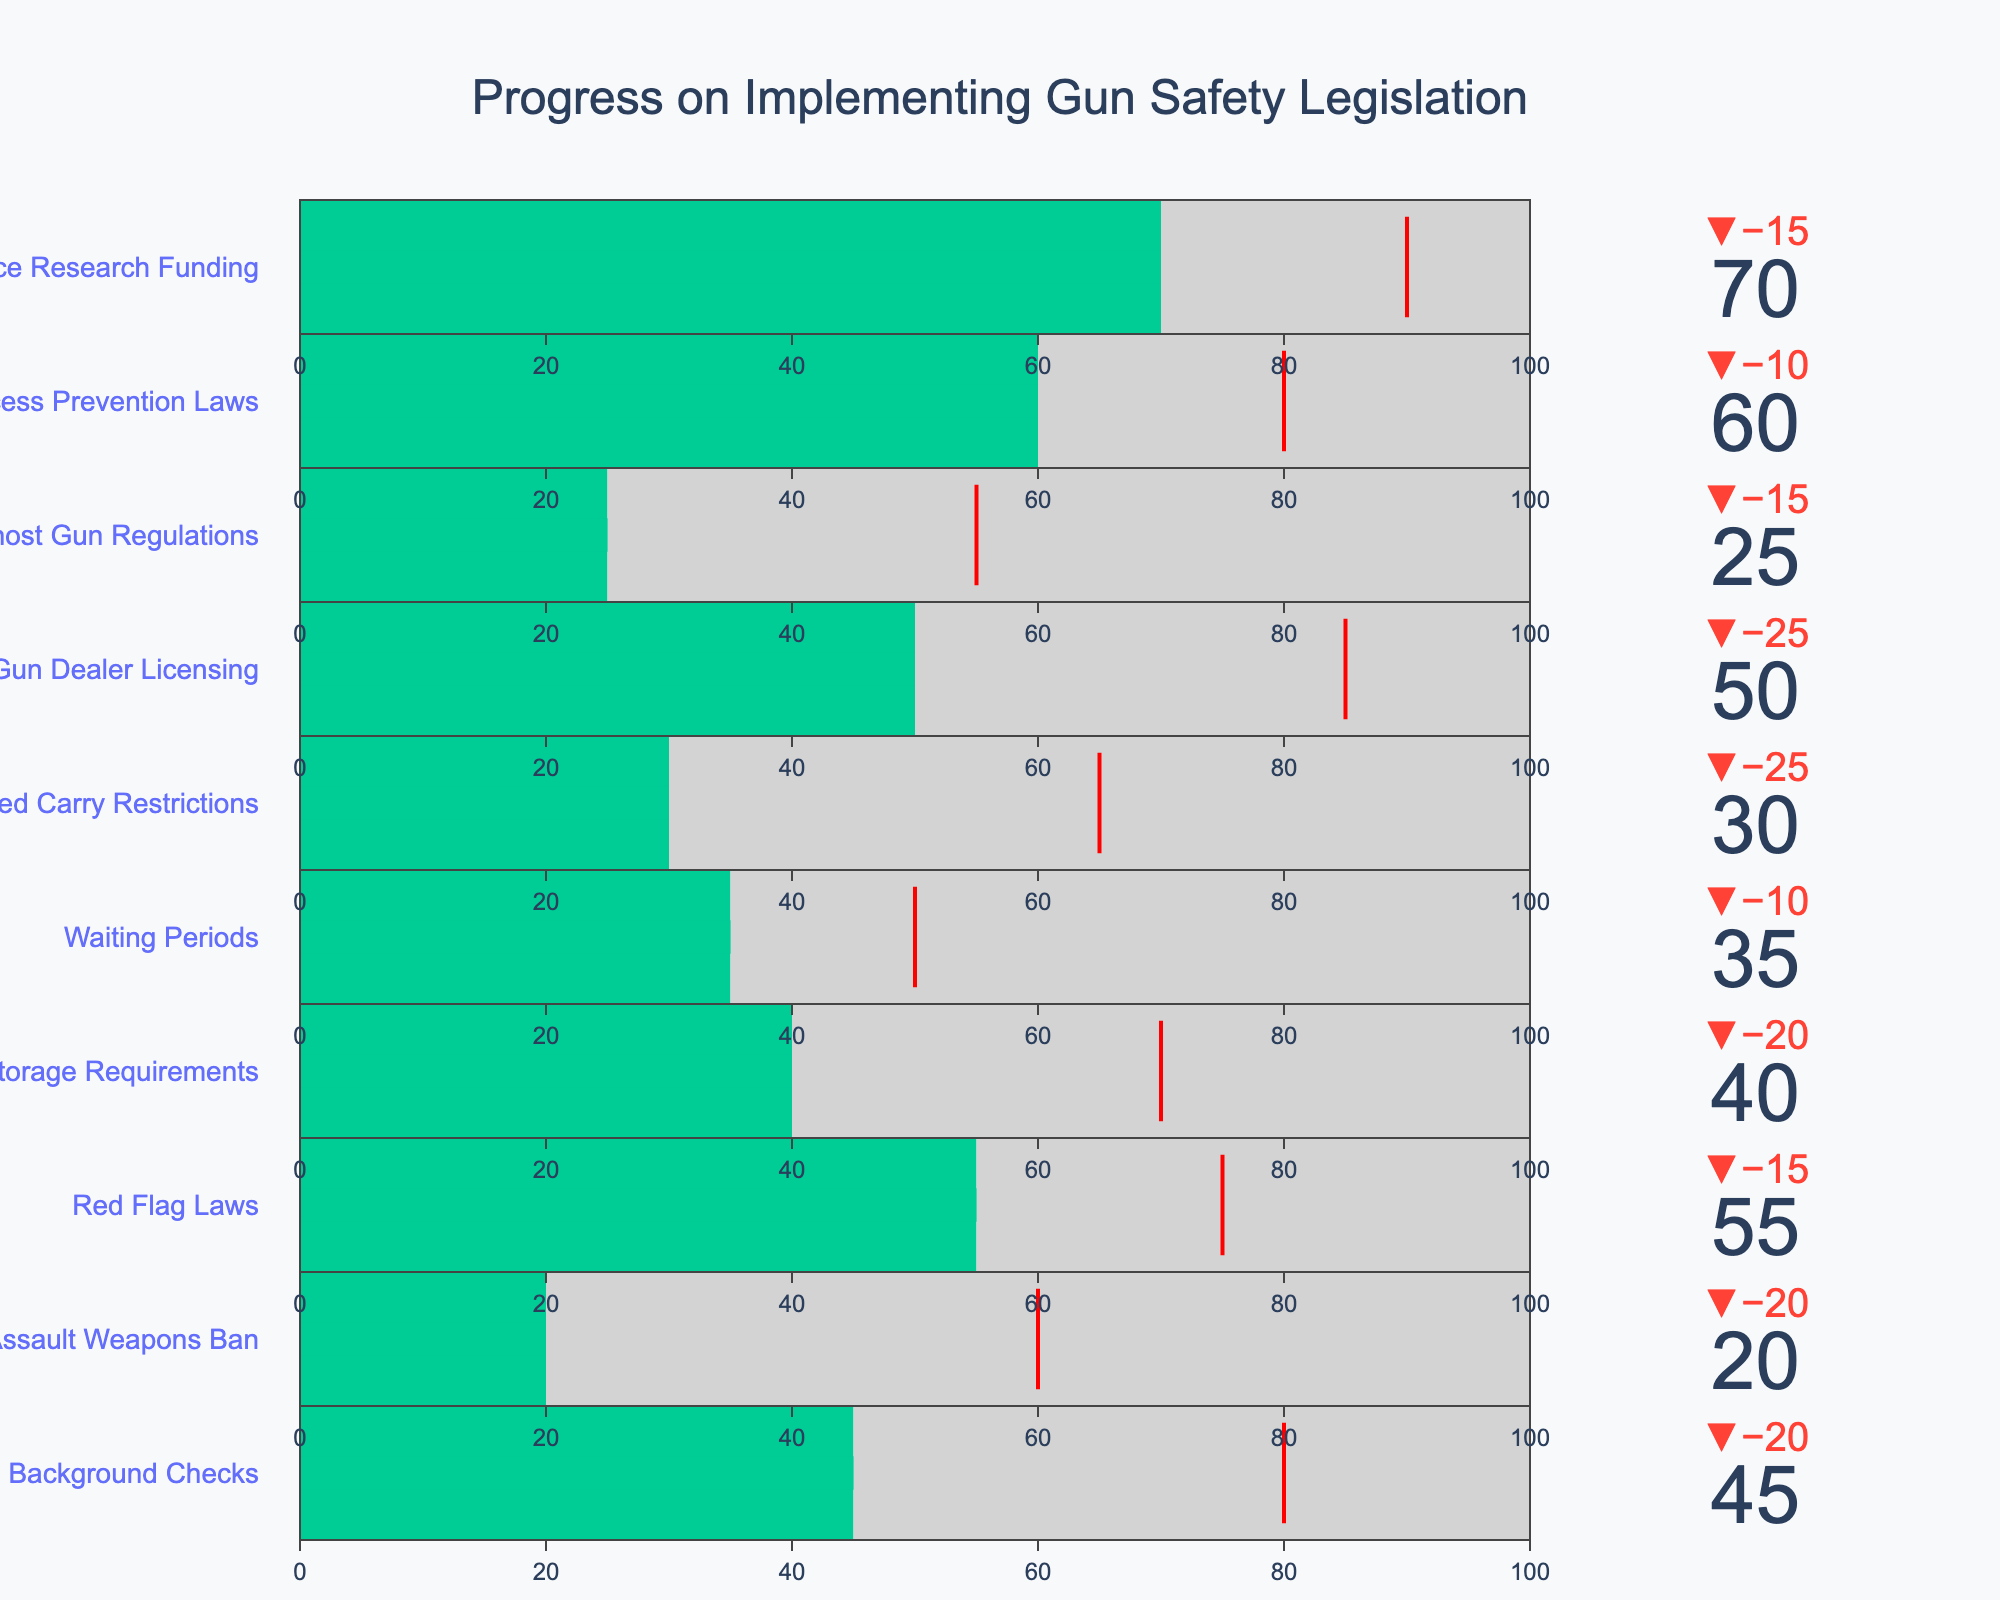How many categories are shown in the figure? The figure contains multiple categories each representing a different aspect of gun safety legislation implementation. By counting the titles of these categories, we can determine the total number, which is 10.
Answer: 10 Which category has the highest actual progress? To determine which category has the highest actual progress, we look at the values labeled under "Actual" for each category. "Gun Violence Research Funding" has the highest actual progress of 70.
Answer: Gun Violence Research Funding How much progress (in percentage points) has the Assault Weapons Ban made in comparison to its target? The "Actual" progress for the Assault Weapons Ban is 20, and the "Target" is 60. The difference between these values gives the progress made compared to the target as 60 - 20 = 40 percentage points.
Answer: 40 What is the average target value across all categories? To find the average target value, sum up all the target values and then divide by the number of categories. The target values are: 80, 60, 75, 70, 50, 65, 85, 55, 80, 90. The sum is 710. Dividing by 10 categories gives the average target value: 710 / 10 = 71.
Answer: 71 Which category shows the largest discrepancy between actual progress and its comparison value? We need to compute the absolute difference between "Actual" and "Comparison" values for each category and identify the largest. Checking each category, we find that "Gun Dealer Licensing" has the largest discrepancy: abs(50 - 75) = 25.
Answer: Gun Dealer Licensing What is the median actual progress value across all categories? We need to list all the actual progress values and find the middle value. The sorted values are: 20, 25, 30, 35, 40, 45, 50, 55, 60, 70. The median value, being the average of the two middle numbers (45 and 50) is (45 + 50) / 2 = 47.5.
Answer: 47.5 If you were to sum up the comparison values for Universal Background Checks and Child Access Prevention Laws, what would be the result? For Universal Background Checks, the comparison value is 65, and for Child Access Prevention Laws, it is 70. Summing these two values gives 65 + 70 = 135.
Answer: 135 When comparing Safe Storage Requirements and Ghost Gun Regulations, which category has a closer actual progress value to its target? For Safe Storage Requirements, the actual progress is 40 with a target of 70 (difference of 30). For Ghost Gun Regulations, the actual progress is 25 with a target of 55 (difference of 30). Both categories have the same difference of 30 points from their targets.
Answer: Both are equally close What is the overall difference between the highest and lowest actual progress values? The highest actual progress is 70 (Gun Violence Research Funding), and the lowest is 20 (Assault Weapons Ban). The overall difference is 70 - 20 = 50.
Answer: 50 